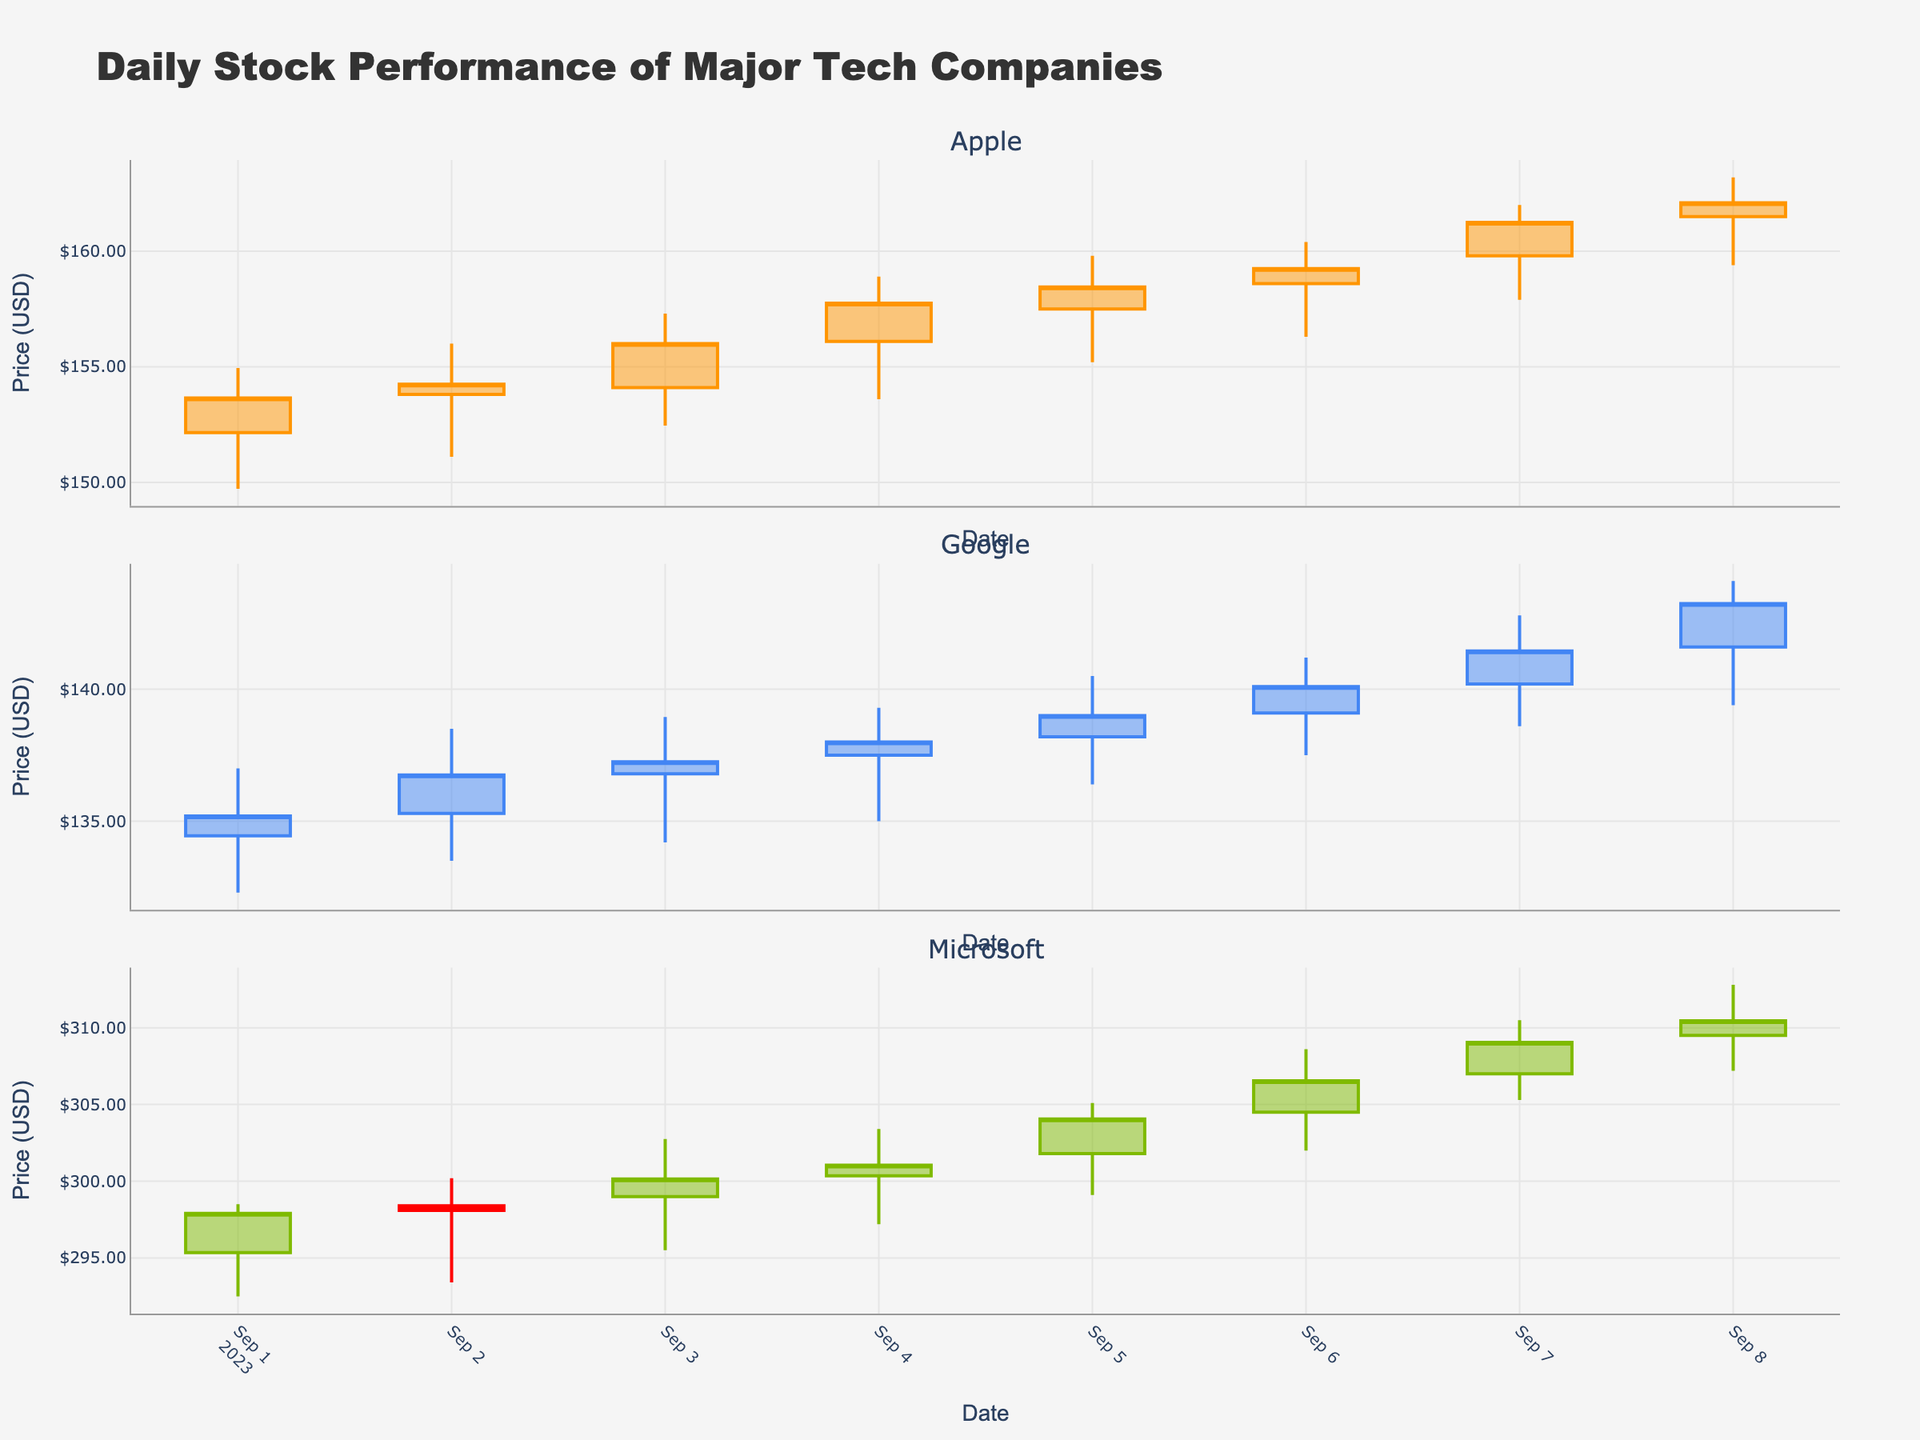What is the title of the figure? The title of the figure is located at the top of the chart to provide a quick overview of what the figure represents.
Answer: Daily Stock Performance of Major Tech Companies Which company experienced the highest closing price over the time period shown? By examining the candlestick plots for each company, you can identify the highest closing price by looking at the uppermost part of the closing price lines.
Answer: Microsoft What was the highest price Google reached, and on which date did it occur? To find this, look at Google's subplot and identify the highest point on the candlesticks. The corresponding date is shown on the x-axis.
Answer: $144.10 on September 8, 2023 Which day did Apple have its highest trading volume? This can be found by looking at the size of the volume bars in Apple's subplot and identifying the tallest one. The corresponding date is shown on the x-axis.
Answer: September 1, 2023 What is the average closing price of Microsoft over the shown time period? You need to sum up the closing prices for each day in Microsoft's subplot and then divide by the number of days.
Answer: ($297.90 + $298.10 + $300.15 + $301.05 + $304.05 + $306.55 + $309.05 + $310.45) / 8 = $303.54 Between Apple, Google, and Microsoft, which company showed the steadiest growth based on the candlestick patterns? Analyze the candlestick patterns across the plots to see which subplot shows the most consistent increase in closing prices over time.
Answer: Apple On which day did Microsoft experience the largest difference between its high and low prices? For Microsoft, calculate the difference between the high and low prices for each day and find the maximum difference. The date corresponding to this maximum difference is the answer.
Answer: September 7, 2023 (High: $310.50, Low: $305.30, Difference: $5.20) Which company had the most volatile stock performance over the period shown? Assess the size and frequency of the candlesticks and shadows (wicks) across the three subplots to identify which company's stock price fluctuated the most.
Answer: Google Compare the closing prices of Apple on September 1 and September 8. Did Apple’s stock price increase or decrease over this period? Check the closing price of Apple on September 1 and compare it to the closing price on September 8 to determine whether it increased or decreased.
Answer: Increase (from $153.65 to $162.10) By how much did Google's closing price increase from September 1 to September 8? Subtract Google's closing price on September 1 from its closing price on September 8 to find the increase amount.
Answer: $143.25 - $135.20 = $8.05 